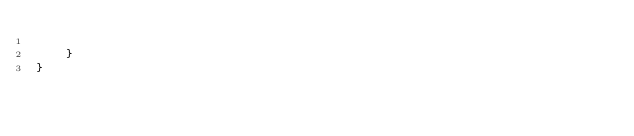<code> <loc_0><loc_0><loc_500><loc_500><_XML_>		
	}
}</code> 